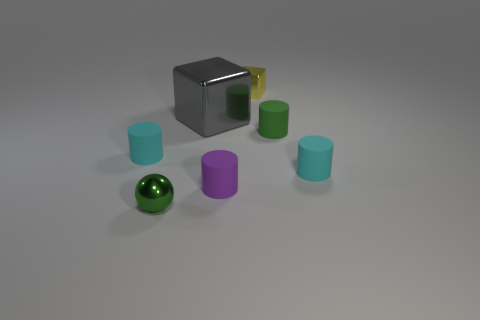Add 2 rubber things. How many objects exist? 9 Subtract all cubes. How many objects are left? 5 Subtract 0 cyan cubes. How many objects are left? 7 Subtract all matte objects. Subtract all small green objects. How many objects are left? 1 Add 4 shiny spheres. How many shiny spheres are left? 5 Add 7 tiny yellow metallic cubes. How many tiny yellow metallic cubes exist? 8 